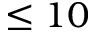<formula> <loc_0><loc_0><loc_500><loc_500>\leq 1 0</formula> 